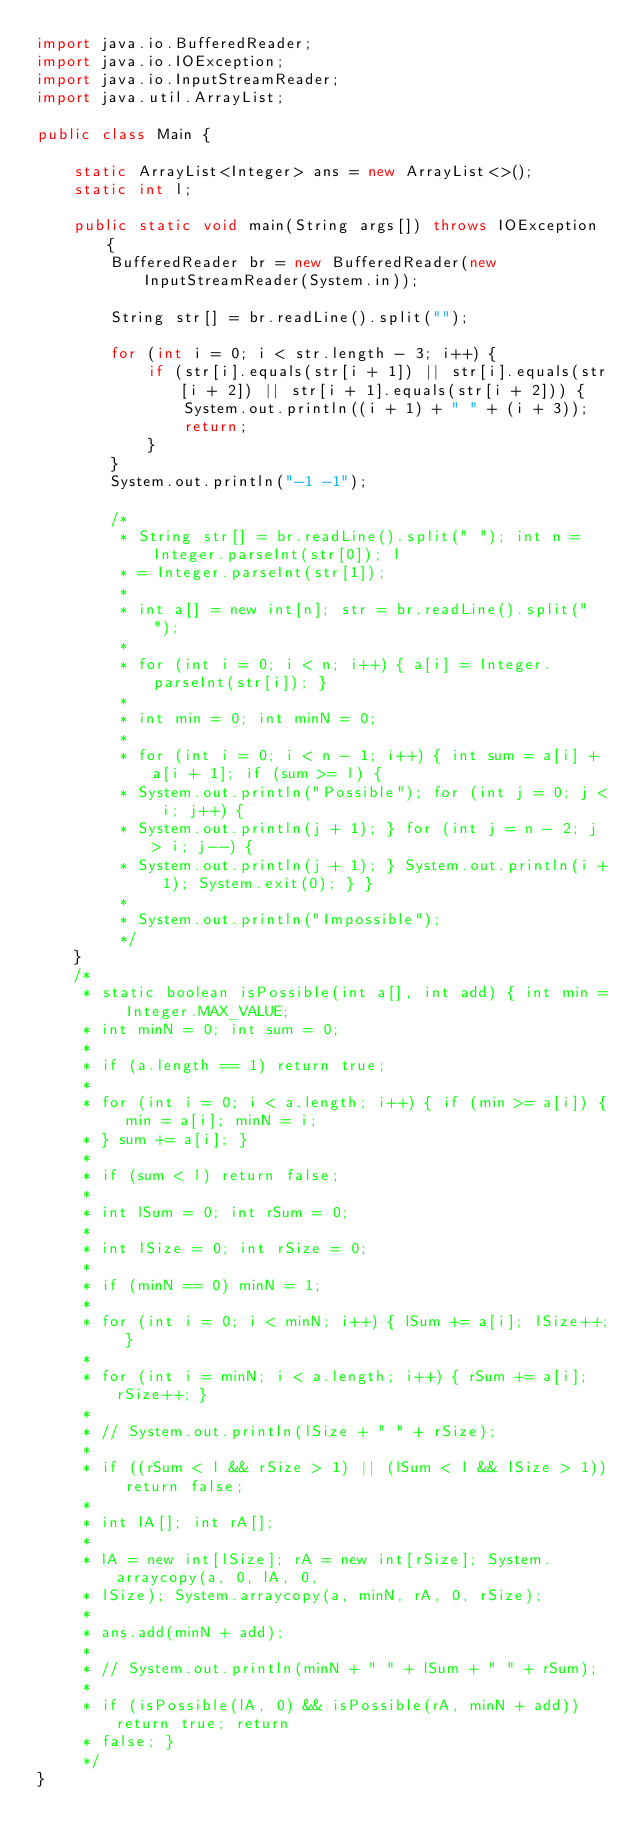Convert code to text. <code><loc_0><loc_0><loc_500><loc_500><_Java_>import java.io.BufferedReader;
import java.io.IOException;
import java.io.InputStreamReader;
import java.util.ArrayList;

public class Main {

	static ArrayList<Integer> ans = new ArrayList<>();
	static int l;

	public static void main(String args[]) throws IOException {
		BufferedReader br = new BufferedReader(new InputStreamReader(System.in));

		String str[] = br.readLine().split("");

		for (int i = 0; i < str.length - 3; i++) {
			if (str[i].equals(str[i + 1]) || str[i].equals(str[i + 2]) || str[i + 1].equals(str[i + 2])) {
				System.out.println((i + 1) + " " + (i + 3));
				return;
			}
		}
		System.out.println("-1 -1");

		/*
		 * String str[] = br.readLine().split(" "); int n = Integer.parseInt(str[0]); l
		 * = Integer.parseInt(str[1]);
		 * 
		 * int a[] = new int[n]; str = br.readLine().split(" ");
		 * 
		 * for (int i = 0; i < n; i++) { a[i] = Integer.parseInt(str[i]); }
		 * 
		 * int min = 0; int minN = 0;
		 * 
		 * for (int i = 0; i < n - 1; i++) { int sum = a[i] + a[i + 1]; if (sum >= l) {
		 * System.out.println("Possible"); for (int j = 0; j < i; j++) {
		 * System.out.println(j + 1); } for (int j = n - 2; j > i; j--) {
		 * System.out.println(j + 1); } System.out.println(i + 1); System.exit(0); } }
		 * 
		 * System.out.println("Impossible");
		 */
	}
	/*
	 * static boolean isPossible(int a[], int add) { int min = Integer.MAX_VALUE;
	 * int minN = 0; int sum = 0;
	 * 
	 * if (a.length == 1) return true;
	 * 
	 * for (int i = 0; i < a.length; i++) { if (min >= a[i]) { min = a[i]; minN = i;
	 * } sum += a[i]; }
	 * 
	 * if (sum < l) return false;
	 * 
	 * int lSum = 0; int rSum = 0;
	 * 
	 * int lSize = 0; int rSize = 0;
	 * 
	 * if (minN == 0) minN = 1;
	 * 
	 * for (int i = 0; i < minN; i++) { lSum += a[i]; lSize++; }
	 * 
	 * for (int i = minN; i < a.length; i++) { rSum += a[i]; rSize++; }
	 * 
	 * // System.out.println(lSize + " " + rSize);
	 * 
	 * if ((rSum < l && rSize > 1) || (lSum < l && lSize > 1)) return false;
	 * 
	 * int lA[]; int rA[];
	 * 
	 * lA = new int[lSize]; rA = new int[rSize]; System.arraycopy(a, 0, lA, 0,
	 * lSize); System.arraycopy(a, minN, rA, 0, rSize);
	 * 
	 * ans.add(minN + add);
	 * 
	 * // System.out.println(minN + " " + lSum + " " + rSum);
	 * 
	 * if (isPossible(lA, 0) && isPossible(rA, minN + add)) return true; return
	 * false; }
	 */
}
</code> 